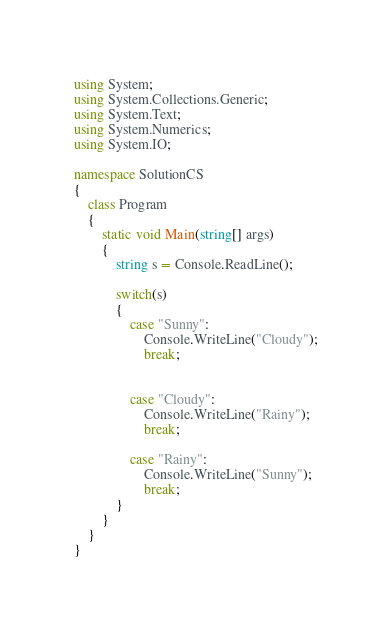<code> <loc_0><loc_0><loc_500><loc_500><_C#_>using System;
using System.Collections.Generic;
using System.Text;
using System.Numerics;
using System.IO;

namespace SolutionCS
{
    class Program
    {
        static void Main(string[] args)
        {
            string s = Console.ReadLine();

            switch(s)
            {
                case "Sunny":
                    Console.WriteLine("Cloudy");
                    break;


                case "Cloudy":
                    Console.WriteLine("Rainy");
                    break;

                case "Rainy":
                    Console.WriteLine("Sunny");
                    break;
            }
        }
    }
}

</code> 